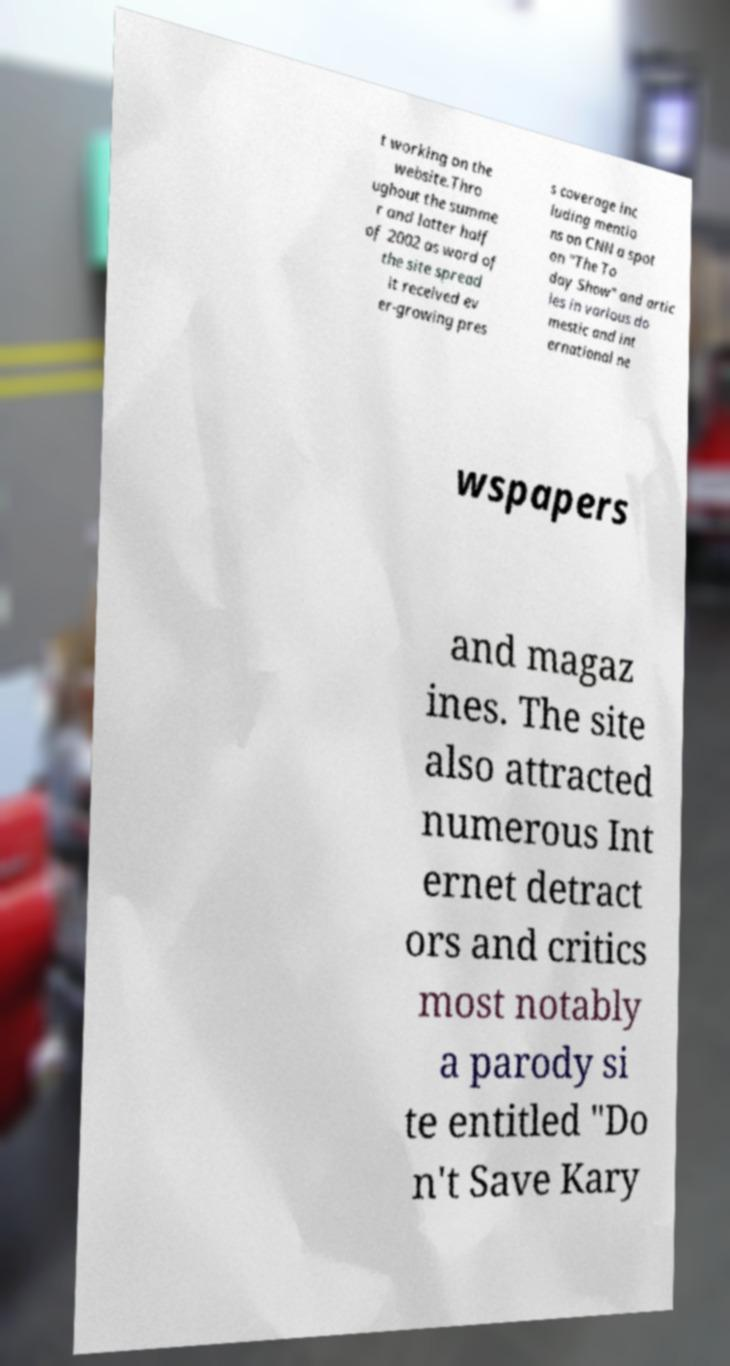Could you assist in decoding the text presented in this image and type it out clearly? t working on the website.Thro ughout the summe r and latter half of 2002 as word of the site spread it received ev er-growing pres s coverage inc luding mentio ns on CNN a spot on "The To day Show" and artic les in various do mestic and int ernational ne wspapers and magaz ines. The site also attracted numerous Int ernet detract ors and critics most notably a parody si te entitled "Do n't Save Kary 